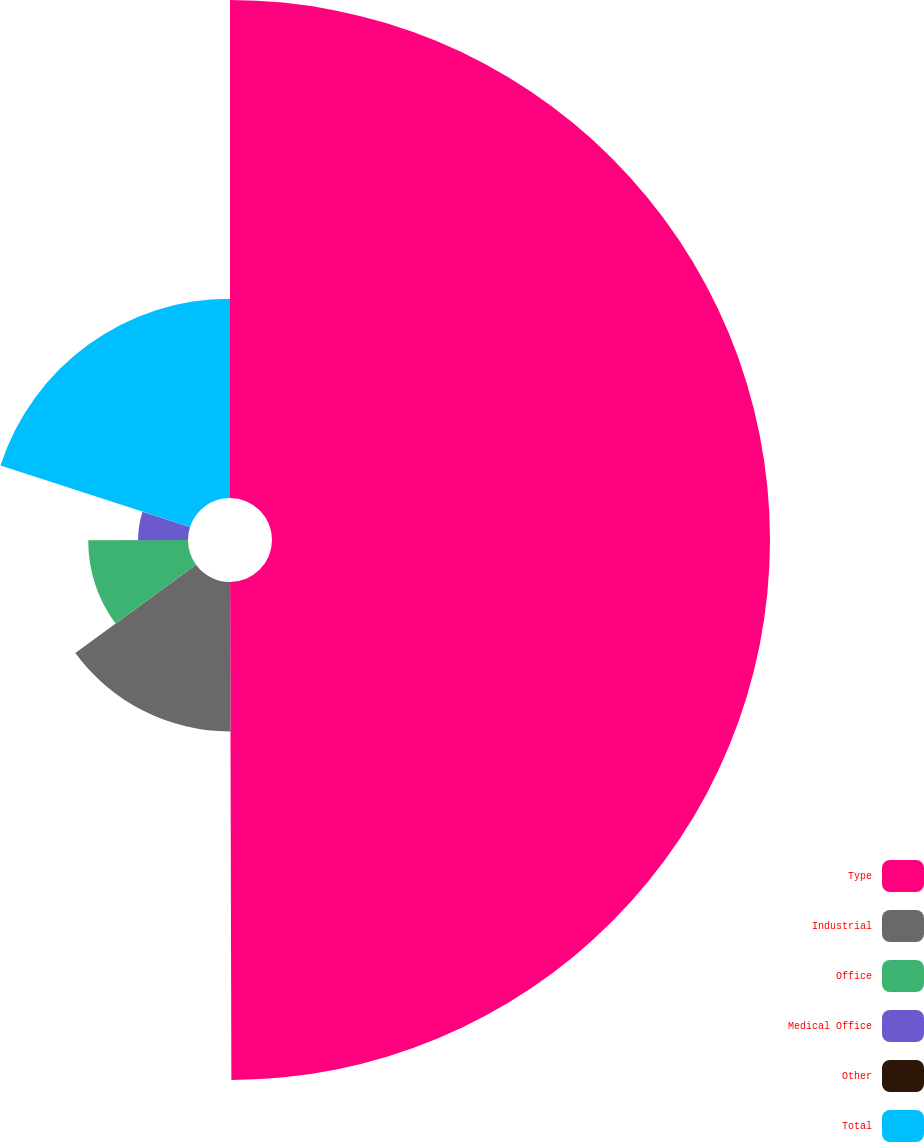Convert chart to OTSL. <chart><loc_0><loc_0><loc_500><loc_500><pie_chart><fcel>Type<fcel>Industrial<fcel>Office<fcel>Medical Office<fcel>Other<fcel>Total<nl><fcel>49.96%<fcel>15.0%<fcel>10.01%<fcel>5.01%<fcel>0.02%<fcel>20.0%<nl></chart> 